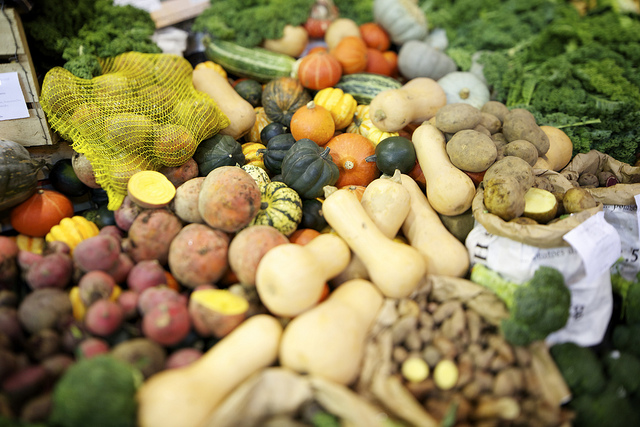<image>What type of fruit is shown? I am not sure what type of fruit is shown. It could be a squash, orange or no fruit at all. What type of fruit is shown? I am not sure what type of fruit is shown. It can be either squash or orange. 